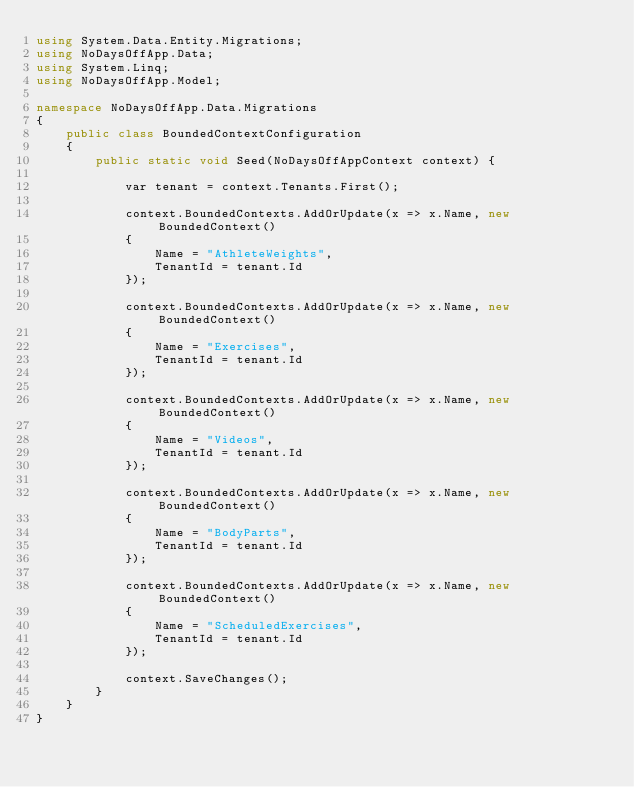<code> <loc_0><loc_0><loc_500><loc_500><_C#_>using System.Data.Entity.Migrations;
using NoDaysOffApp.Data;
using System.Linq;
using NoDaysOffApp.Model;

namespace NoDaysOffApp.Data.Migrations
{
    public class BoundedContextConfiguration
    {
        public static void Seed(NoDaysOffAppContext context) {

            var tenant = context.Tenants.First();

            context.BoundedContexts.AddOrUpdate(x => x.Name, new BoundedContext()
            {
                Name = "AthleteWeights",
                TenantId = tenant.Id
            });

            context.BoundedContexts.AddOrUpdate(x => x.Name, new BoundedContext()
            {
                Name = "Exercises",
                TenantId = tenant.Id
            });

            context.BoundedContexts.AddOrUpdate(x => x.Name, new BoundedContext()
            {
                Name = "Videos",
                TenantId = tenant.Id
            });

            context.BoundedContexts.AddOrUpdate(x => x.Name, new BoundedContext()
            {
                Name = "BodyParts",
                TenantId = tenant.Id
            });

            context.BoundedContexts.AddOrUpdate(x => x.Name, new BoundedContext()
            {
                Name = "ScheduledExercises",
                TenantId = tenant.Id
            });

            context.SaveChanges();
        }
    }
}
</code> 